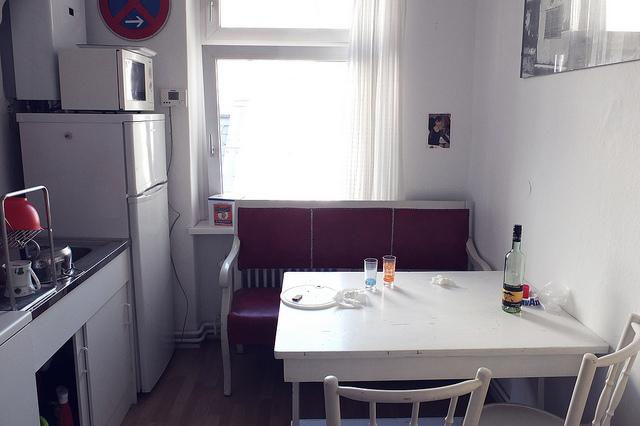What room is this in the house?
Answer briefly. Kitchen. Is the bench all wood?
Write a very short answer. No. Which color is dominant?
Give a very brief answer. White. 